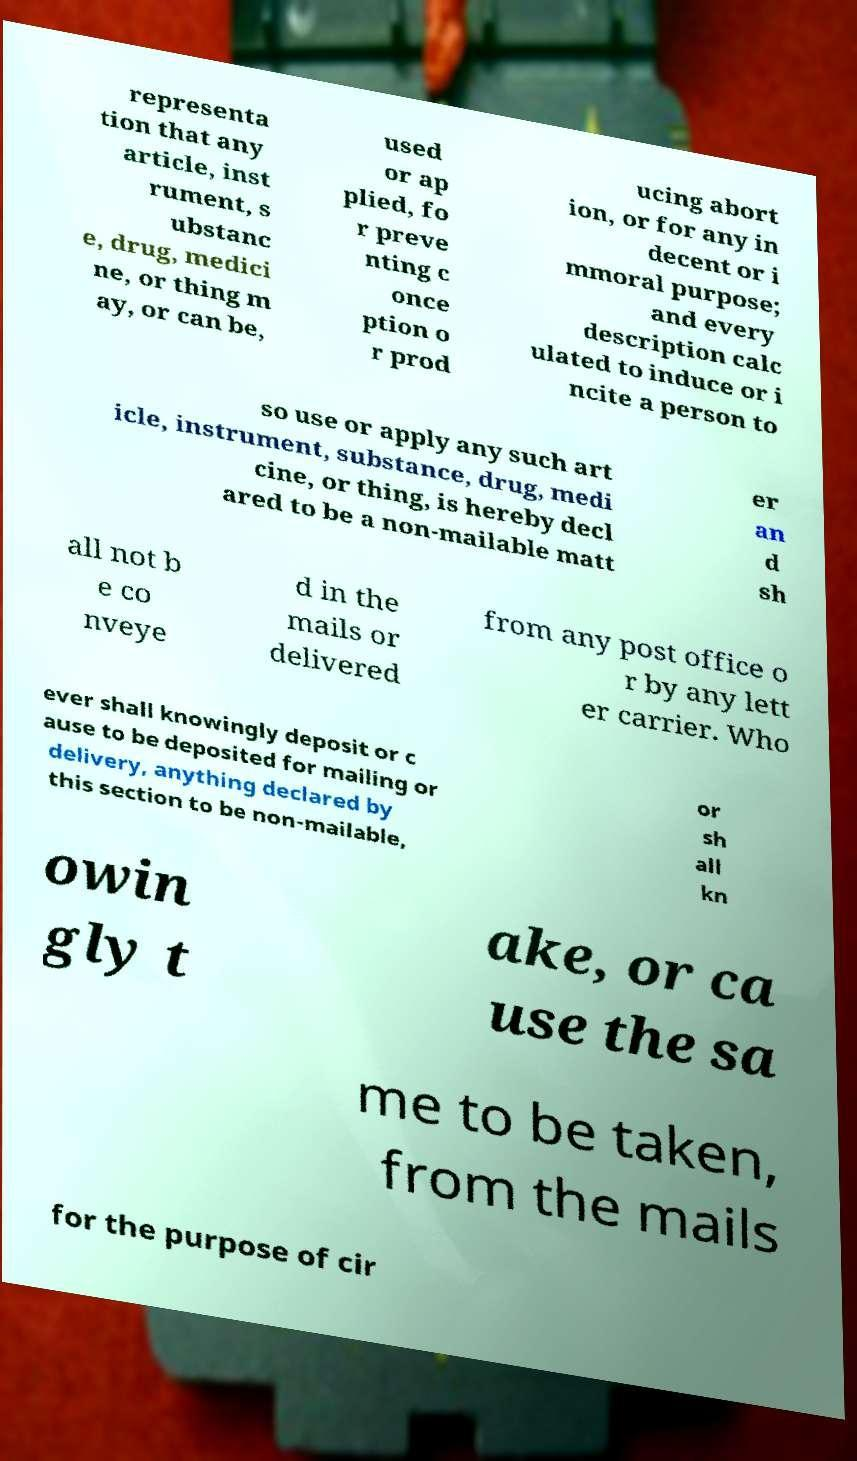What messages or text are displayed in this image? I need them in a readable, typed format. representa tion that any article, inst rument, s ubstanc e, drug, medici ne, or thing m ay, or can be, used or ap plied, fo r preve nting c once ption o r prod ucing abort ion, or for any in decent or i mmoral purpose; and every description calc ulated to induce or i ncite a person to so use or apply any such art icle, instrument, substance, drug, medi cine, or thing, is hereby decl ared to be a non-mailable matt er an d sh all not b e co nveye d in the mails or delivered from any post office o r by any lett er carrier. Who ever shall knowingly deposit or c ause to be deposited for mailing or delivery, anything declared by this section to be non-mailable, or sh all kn owin gly t ake, or ca use the sa me to be taken, from the mails for the purpose of cir 